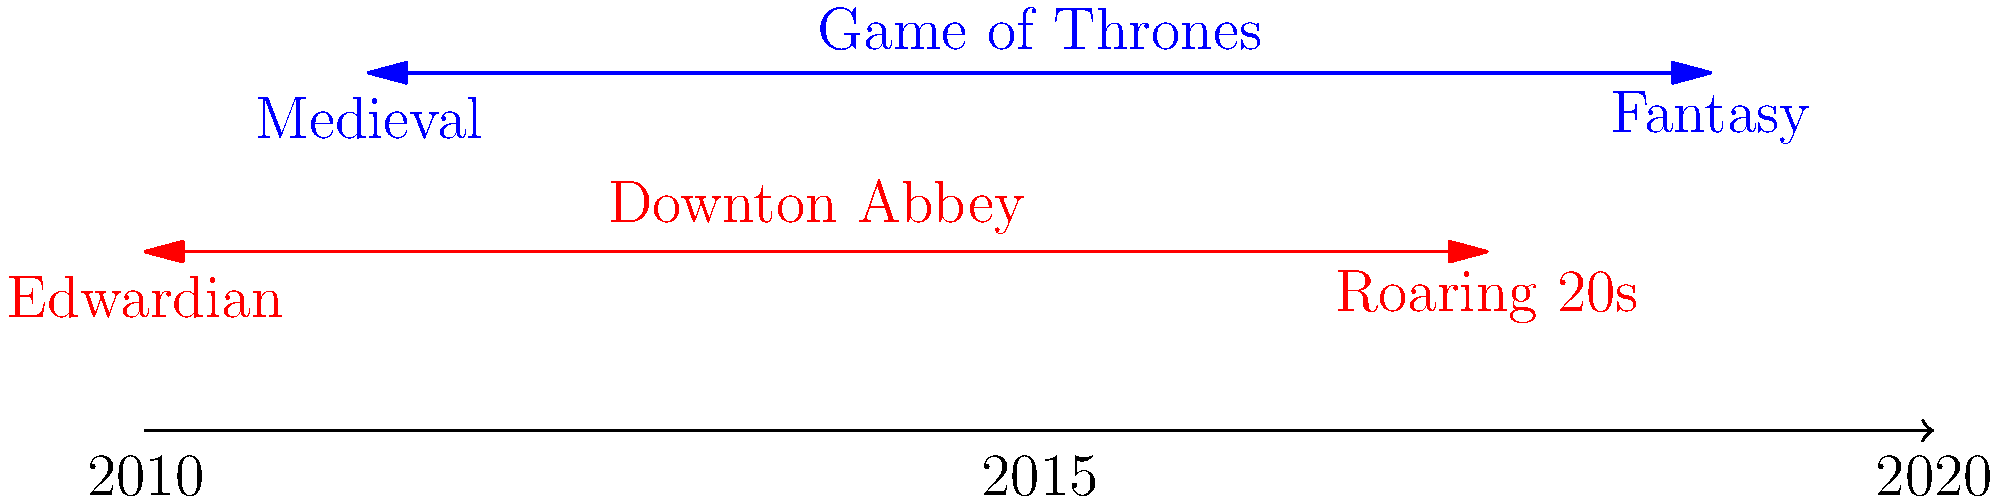Analyze the evolution of costume designs in 'Game of Thrones' and 'Downton Abbey' as depicted in the timeline. How do these changes reflect the narrative progression and historical context of each series? Provide specific examples from key characters in both shows to support your analysis. 1. Game of Thrones costume evolution:
   a) Starts with medieval-inspired designs (2011)
   b) Gradually incorporates more fantasy elements (2019)
   c) Examples: Daenerys' outfits evolve from simple Dothraki clothing to elaborate dragon-inspired designs
   d) Cersei's costumes shift from ornate gowns to militaristic styles, reflecting her rise to power

2. Downton Abbey costume evolution:
   a) Begins with Edwardian era designs (2010)
   b) Progresses to 1920s "Roaring Twenties" styles (2015)
   c) Examples: Lady Mary's wardrobe transitions from corseted gowns to loose-fitting flapper dresses
   d) Downstairs staff uniforms subtly change to reflect modernizing standards of service

3. Narrative progression reflection:
   a) Game of Thrones: Costumes become more extravagant and fantastical as the story moves towards its climax
   b) Downton Abbey: Outfits modernize, mirroring the societal changes of post-WWI Britain

4. Historical context:
   a) Game of Thrones: Though set in a fantasy world, costumes draw from various historical periods
   b) Downton Abbey: Accurately portrays the rapid fashion changes of the early 20th century

5. Character development through costumes:
   a) Game of Thrones: Sansa Stark's outfits reflect her journey from naive girl to powerful leader
   b) Downton Abbey: Tom Branson's wardrobe evolution from chauffeur to family member

6. Cultural influences:
   a) Game of Thrones: Incorporates diverse cultural elements (e.g., Dothraki, Unsullied)
   b) Downton Abbey: Shows the influence of American culture on British fashion in the 1920s
Answer: Both shows' costumes evolve to reflect narrative progression and historical context: GoT moves from medieval to fantasy, while Downton Abbey transitions from Edwardian to 1920s styles, enhancing character development and cultural representation. 